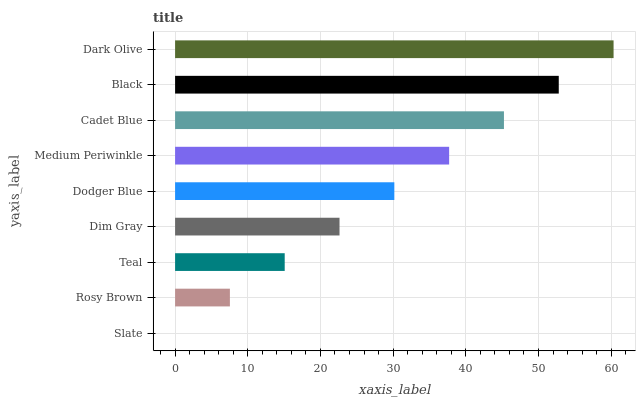Is Slate the minimum?
Answer yes or no. Yes. Is Dark Olive the maximum?
Answer yes or no. Yes. Is Rosy Brown the minimum?
Answer yes or no. No. Is Rosy Brown the maximum?
Answer yes or no. No. Is Rosy Brown greater than Slate?
Answer yes or no. Yes. Is Slate less than Rosy Brown?
Answer yes or no. Yes. Is Slate greater than Rosy Brown?
Answer yes or no. No. Is Rosy Brown less than Slate?
Answer yes or no. No. Is Dodger Blue the high median?
Answer yes or no. Yes. Is Dodger Blue the low median?
Answer yes or no. Yes. Is Cadet Blue the high median?
Answer yes or no. No. Is Slate the low median?
Answer yes or no. No. 